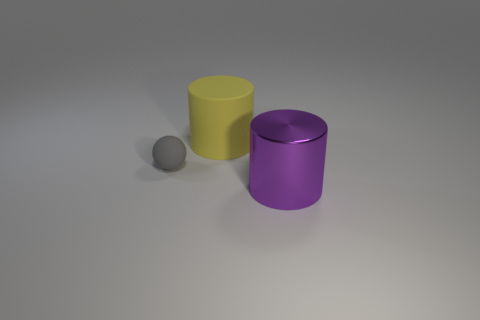Add 3 cubes. How many objects exist? 6 Subtract all cylinders. How many objects are left? 1 Subtract 2 cylinders. How many cylinders are left? 0 Subtract all green cylinders. Subtract all purple balls. How many cylinders are left? 2 Subtract all brown balls. How many yellow cylinders are left? 1 Subtract all matte things. Subtract all yellow things. How many objects are left? 0 Add 3 tiny gray things. How many tiny gray things are left? 4 Add 2 gray rubber things. How many gray rubber things exist? 3 Subtract all purple cylinders. How many cylinders are left? 1 Subtract 0 gray cylinders. How many objects are left? 3 